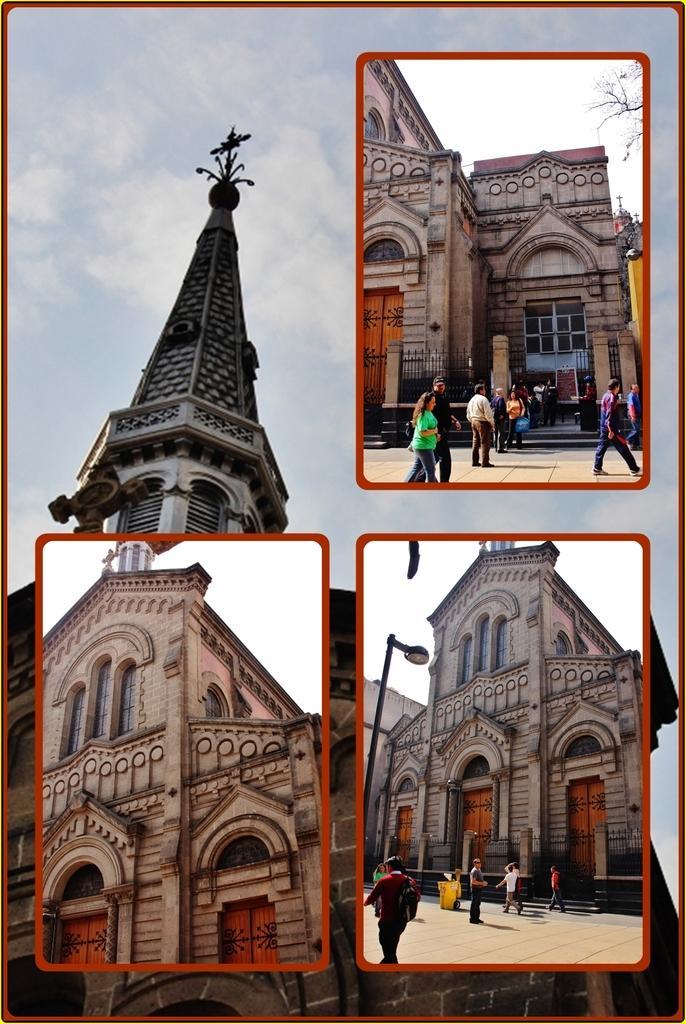Could you give a brief overview of what you see in this image? It is an edited image, there is a monument and on the picture of the monument there are other three pictures, they are different parts of the monument, in the first and third image there are few people in front of the monument. 